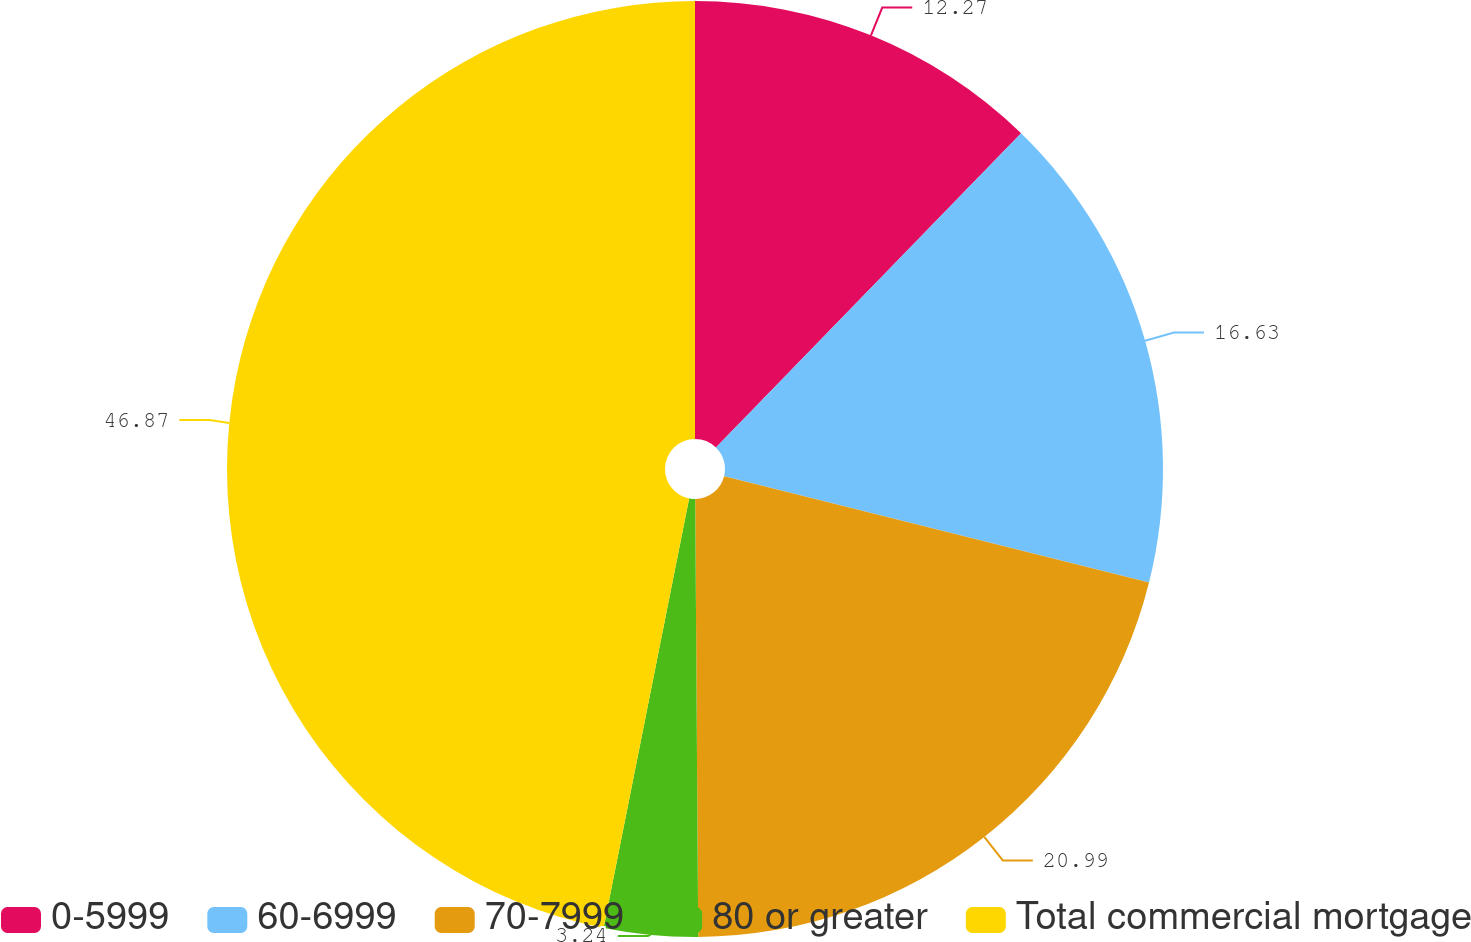<chart> <loc_0><loc_0><loc_500><loc_500><pie_chart><fcel>0-5999<fcel>60-6999<fcel>70-7999<fcel>80 or greater<fcel>Total commercial mortgage<nl><fcel>12.27%<fcel>16.63%<fcel>20.99%<fcel>3.24%<fcel>46.87%<nl></chart> 